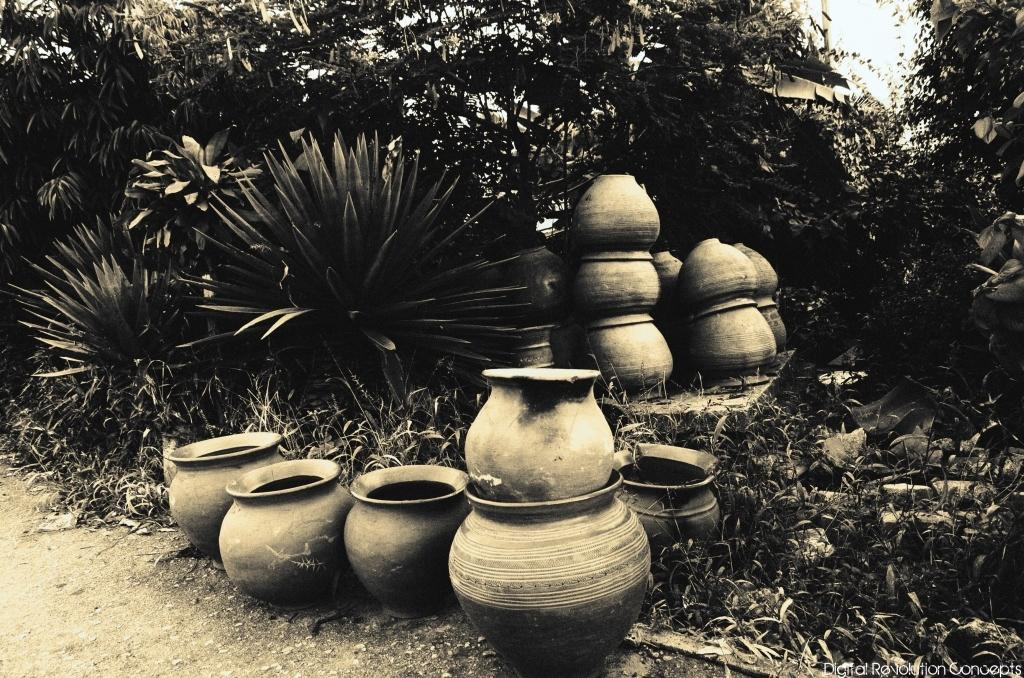What objects are present in the image? There are pots in the image. What can be seen in the background of the image? There are trees and the sky visible in the background of the image. What type of vegetation is at the bottom of the image? There is grass at the bottom of the image. What type of hair can be seen on the pots in the image? There is no hair present on the pots in the image. What musical instrument is being played in the background of the image? There is no musical instrument being played in the image; it only features pots, trees, sky, and grass. 